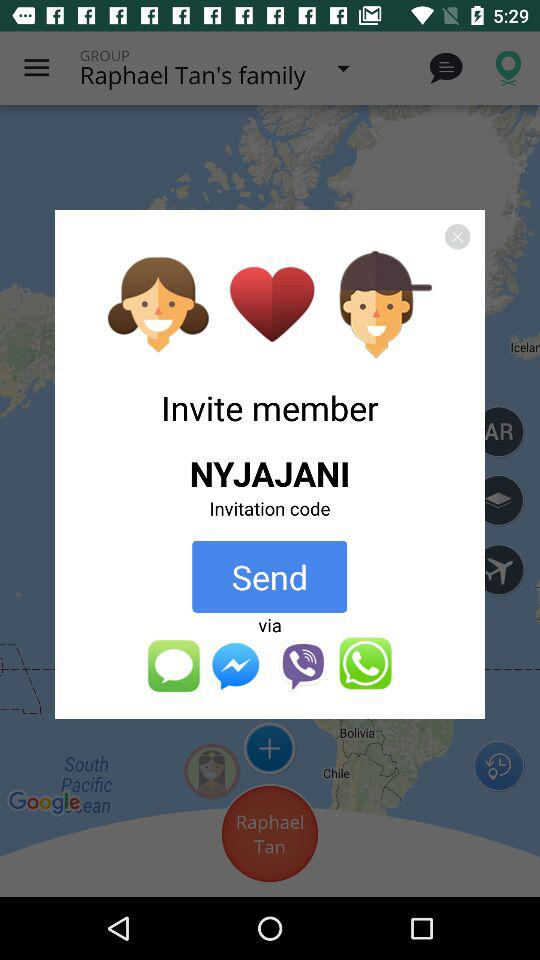Where is the user located?
When the provided information is insufficient, respond with <no answer>. <no answer> 